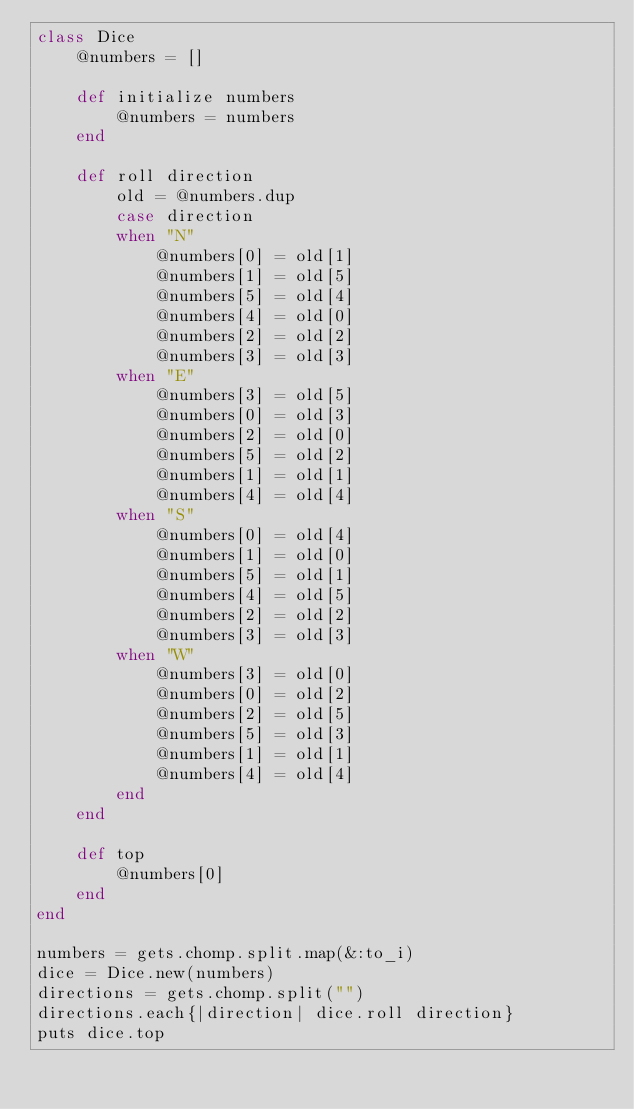<code> <loc_0><loc_0><loc_500><loc_500><_Ruby_>class Dice
    @numbers = []

    def initialize numbers
        @numbers = numbers
    end

    def roll direction
        old = @numbers.dup
        case direction
        when "N"
            @numbers[0] = old[1]
            @numbers[1] = old[5] 
            @numbers[5] = old[4]
            @numbers[4] = old[0]
            @numbers[2] = old[2]
            @numbers[3] = old[3]
        when "E"
            @numbers[3] = old[5]
            @numbers[0] = old[3] 
            @numbers[2] = old[0]
            @numbers[5] = old[2]
            @numbers[1] = old[1]
            @numbers[4] = old[4]
        when "S"
            @numbers[0] = old[4]
            @numbers[1] = old[0] 
            @numbers[5] = old[1]
            @numbers[4] = old[5]
            @numbers[2] = old[2]
            @numbers[3] = old[3]
        when "W"
            @numbers[3] = old[0]
            @numbers[0] = old[2] 
            @numbers[2] = old[5]
            @numbers[5] = old[3]
            @numbers[1] = old[1]
            @numbers[4] = old[4]
        end
    end

    def top
        @numbers[0]
    end
end

numbers = gets.chomp.split.map(&:to_i)
dice = Dice.new(numbers)
directions = gets.chomp.split("")
directions.each{|direction| dice.roll direction}
puts dice.top</code> 